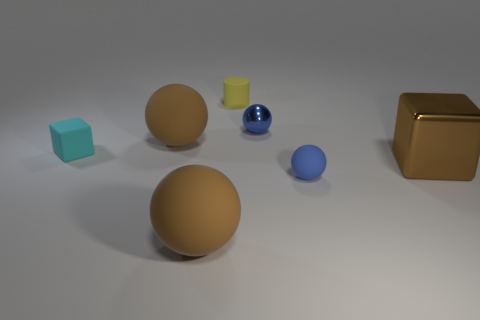There is a small metallic thing; does it have the same color as the tiny sphere in front of the tiny cyan object?
Keep it short and to the point. Yes. The large cube is what color?
Keep it short and to the point. Brown. What number of objects are big red metallic cylinders or large brown rubber objects?
Ensure brevity in your answer.  2. There is another sphere that is the same size as the blue matte ball; what material is it?
Provide a short and direct response. Metal. How big is the brown object that is on the right side of the yellow rubber object?
Give a very brief answer. Large. What is the small yellow cylinder made of?
Give a very brief answer. Rubber. How many objects are brown rubber objects that are in front of the brown metallic block or brown spheres behind the brown metallic block?
Keep it short and to the point. 2. How many other things are there of the same color as the cylinder?
Keep it short and to the point. 0. Does the tiny metallic thing have the same shape as the large brown rubber thing that is behind the large block?
Offer a very short reply. Yes. Are there fewer blocks to the left of the yellow cylinder than matte objects in front of the small cyan cube?
Ensure brevity in your answer.  Yes. 